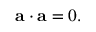<formula> <loc_0><loc_0><loc_500><loc_500>{ a } \cdot { a } = 0 .</formula> 